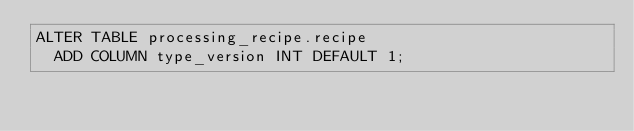Convert code to text. <code><loc_0><loc_0><loc_500><loc_500><_SQL_>ALTER TABLE processing_recipe.recipe
  ADD COLUMN type_version INT DEFAULT 1;</code> 